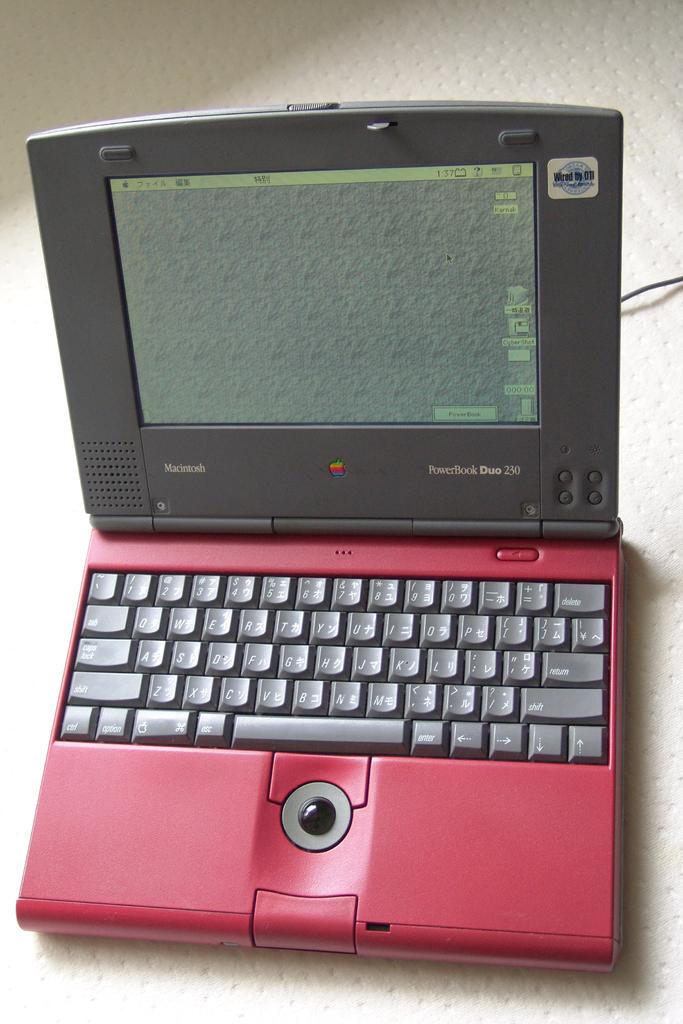Who makes this computer?
Offer a terse response. Apple. 